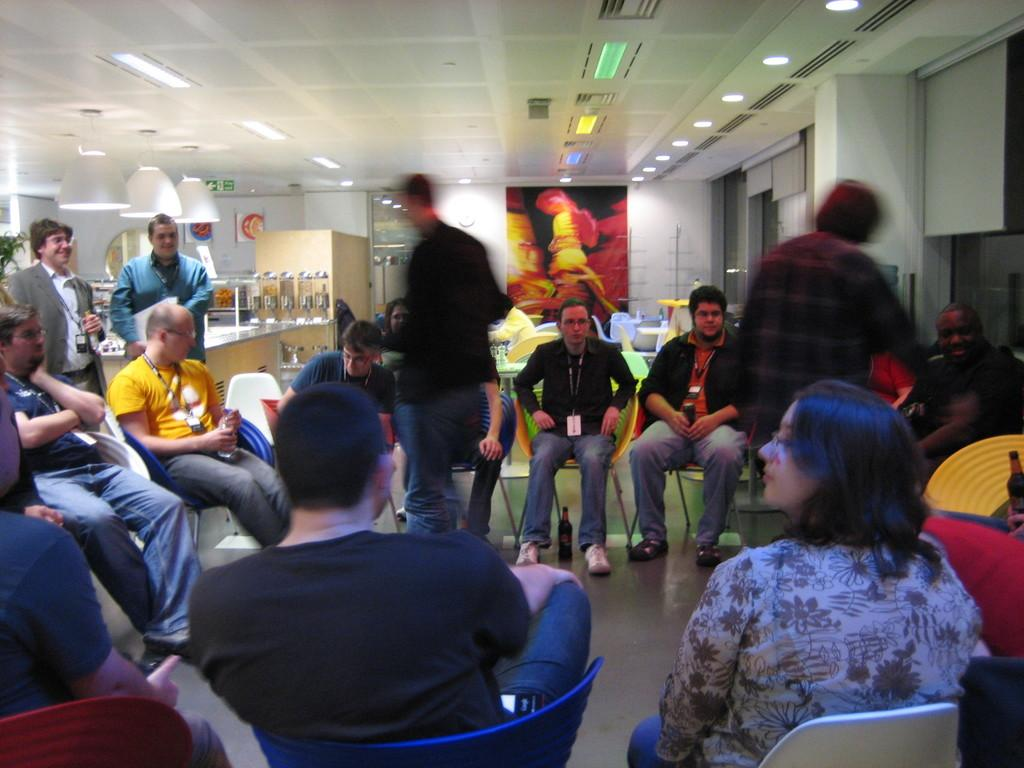How many people are in the image? There is a group of people in the image, but the exact number cannot be determined from the provided facts. What type of furniture is visible in the image? There are chairs and tables in the image. What can be used for illumination in the image? There are lights in the image. What is the color of the wall in the image? The wall in the image is white in color. What type of decoration or signage is present in the image? There is a banner in the image. What type of engine is visible in the image? There is no engine present in the image. What type of sign is hanging on the wall in the image? The provided facts do not mention a sign hanging on the wall; only a banner is mentioned. 